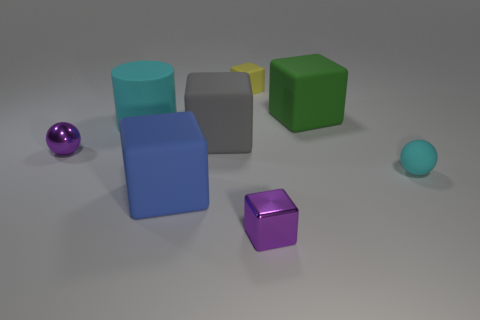How many tiny yellow things are the same material as the big gray thing?
Offer a very short reply. 1. How many matte things are cyan cubes or green blocks?
Provide a short and direct response. 1. Is the shape of the large matte object that is in front of the purple metallic ball the same as the tiny yellow rubber object that is behind the blue rubber block?
Your response must be concise. Yes. What is the color of the object that is in front of the cyan matte sphere and to the left of the yellow object?
Offer a very short reply. Blue. Is the size of the gray rubber object that is in front of the green thing the same as the yellow rubber thing that is on the right side of the gray block?
Provide a succinct answer. No. How many shiny objects have the same color as the large rubber cylinder?
Provide a succinct answer. 0. How many small things are yellow metallic cylinders or metallic cubes?
Give a very brief answer. 1. Do the cyan thing that is to the left of the cyan rubber sphere and the purple block have the same material?
Provide a short and direct response. No. There is a sphere that is on the left side of the yellow matte block; what color is it?
Your answer should be compact. Purple. Is there another rubber cube of the same size as the blue block?
Your answer should be very brief. Yes. 